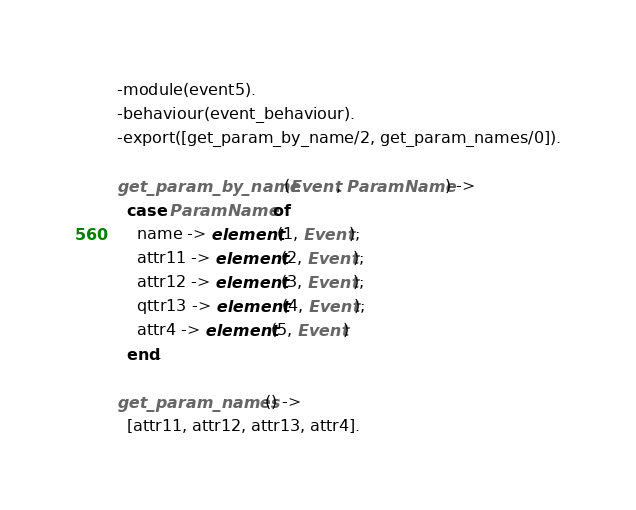<code> <loc_0><loc_0><loc_500><loc_500><_Erlang_>-module(event5).
-behaviour(event_behaviour).
-export([get_param_by_name/2, get_param_names/0]).

get_param_by_name(Event, ParamName) ->
  case ParamName of
    name -> element(1, Event);
    attr11 -> element(2, Event);
    attr12 -> element(3, Event);
    qttr13 -> element(4, Event);
    attr4 -> element(5, Event)
  end.

get_param_names() ->
  [attr11, attr12, attr13, attr4].</code> 